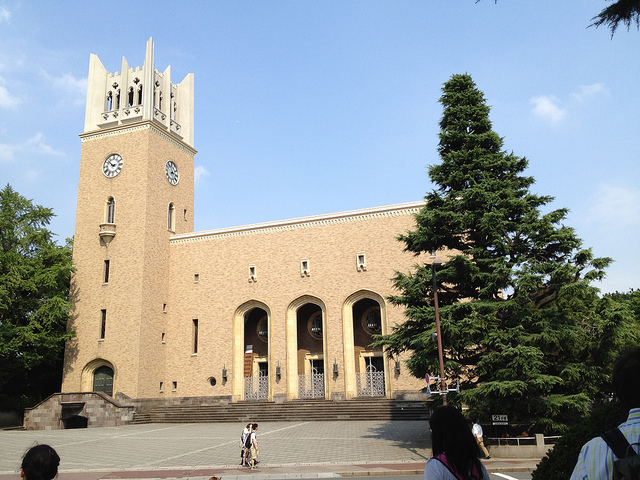<image>What culture has influenced this architecture? It is ambiguous to determine which culture has influenced this architecture. It could be Roman, Medieval, European, Spanish, Victorian, or Greek. What culture has influenced this architecture? I don't know what culture has influenced this architecture. It can be influenced by 'roman', 'england', 'medieval', 'european', 'spanish', 'church', 'victorian' or 'greek'. 